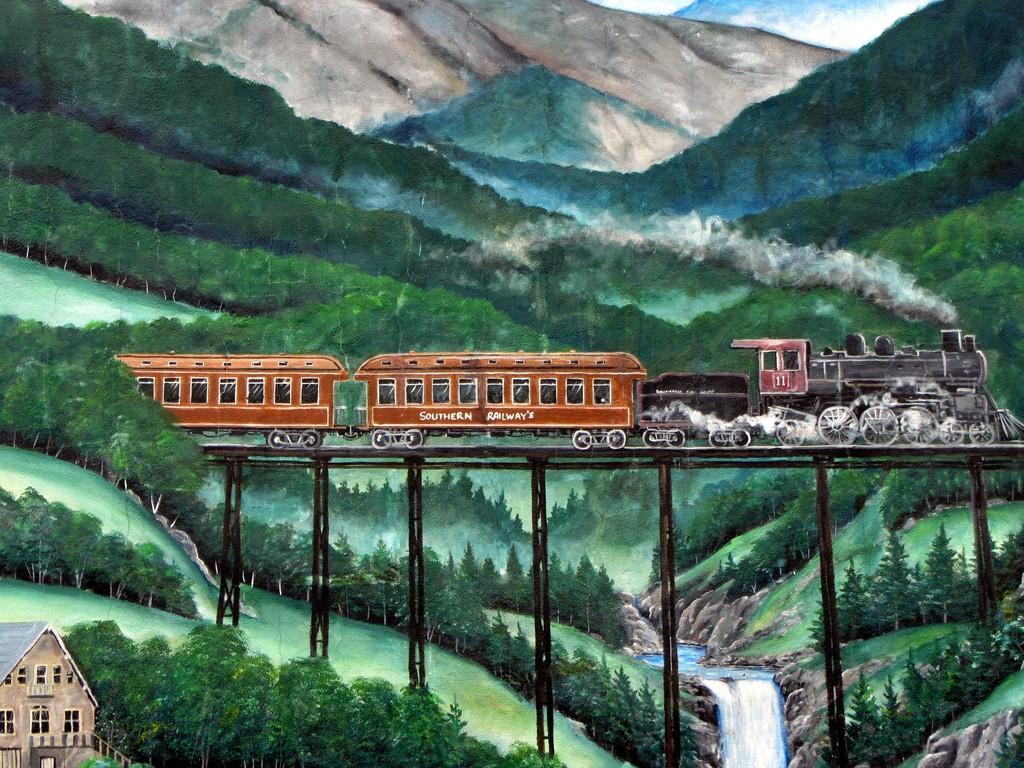Can you describe this image briefly? Here this is a setup, in which we can see a train present on a track and we can also see houses present and we can also see mountains covered with grass and plants and we can also see other trees present and we can see water flowing through a place. 